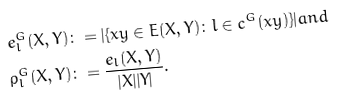Convert formula to latex. <formula><loc_0><loc_0><loc_500><loc_500>e ^ { G } _ { l } ( X , Y ) & \colon = | \{ x y \in E ( X , Y ) \colon l \in c ^ { G } ( x y ) \} | a n d \\ \rho ^ { G } _ { l } ( X , Y ) & \colon = \frac { e _ { l } ( X , Y ) } { | X | | Y | } .</formula> 